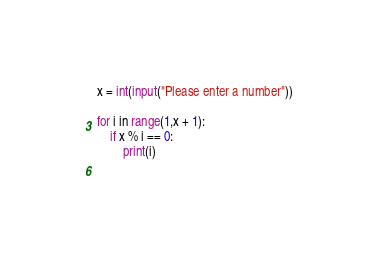Convert code to text. <code><loc_0><loc_0><loc_500><loc_500><_Python_>x = int(input("Please enter a number"))

for i in range(1,x + 1):
    if x % i == 0:
        print(i)
        
</code> 